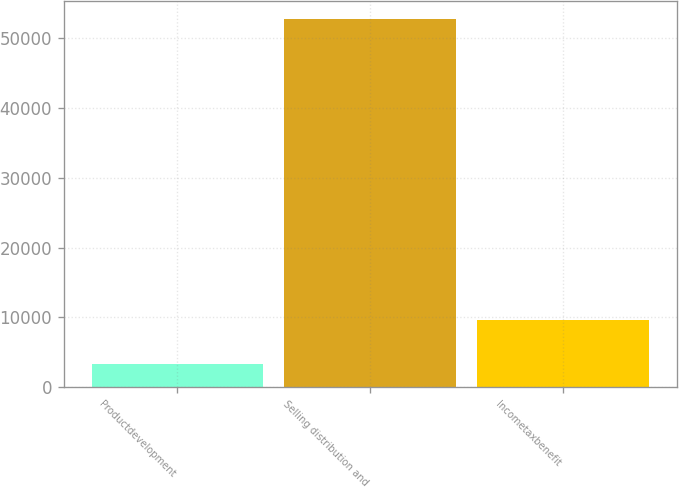Convert chart. <chart><loc_0><loc_0><loc_500><loc_500><bar_chart><fcel>Productdevelopment<fcel>Selling distribution and<fcel>Incometaxbenefit<nl><fcel>3312<fcel>52720<fcel>9574<nl></chart> 